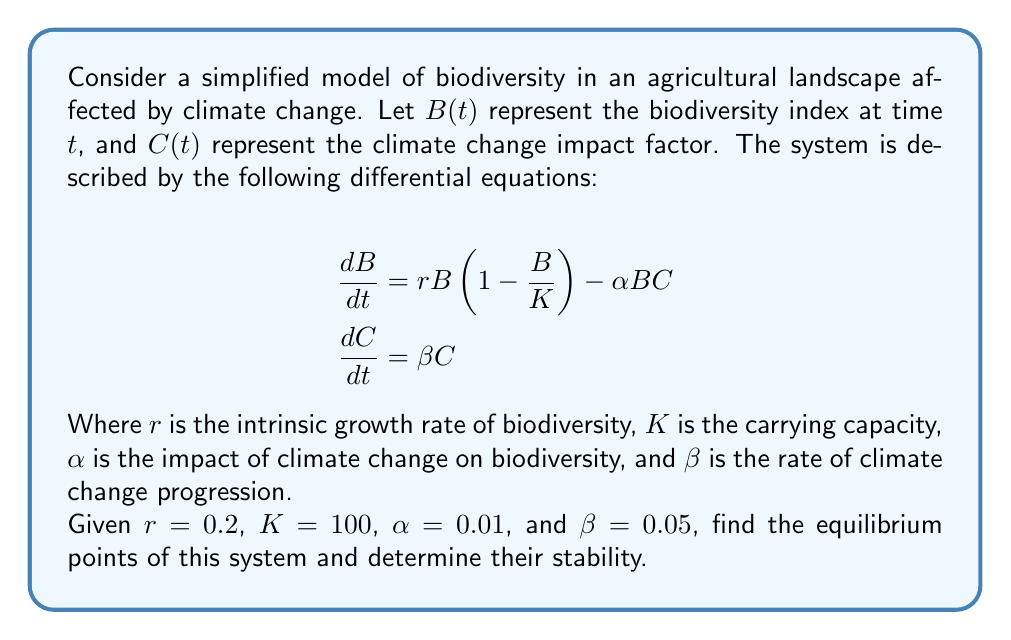Solve this math problem. To find the equilibrium points, we set both derivatives to zero:

1) $\frac{dB}{dt} = 0$ and $\frac{dC}{dt} = 0$

2) From $\frac{dC}{dt} = \beta C = 0$, we get:
   $C = 0$ (since $\beta \neq 0$)

3) Substituting this into $\frac{dB}{dt} = 0$:
   $rB(1 - \frac{B}{K}) - \alpha B(0) = 0$
   $0.2B(1 - \frac{B}{100}) = 0$

4) Solving this equation:
   $B = 0$ or $B = 100$

5) Therefore, we have two equilibrium points: $(B, C) = (0, 0)$ and $(100, 0)$

6) To determine stability, we calculate the Jacobian matrix:
   $$J = \begin{bmatrix}
   r - \frac{2rB}{K} - \alpha C & -\alpha B \\
   0 & \beta
   \end{bmatrix}$$

7) At $(0, 0)$:
   $$J_{(0,0)} = \begin{bmatrix}
   0.2 & 0 \\
   0 & 0.05
   \end{bmatrix}$$
   Eigenvalues: $\lambda_1 = 0.2$, $\lambda_2 = 0.05$
   Both positive, so $(0, 0)$ is an unstable node.

8) At $(100, 0)$:
   $$J_{(100,0)} = \begin{bmatrix}
   -0.2 & -1 \\
   0 & 0.05
   \end{bmatrix}$$
   Eigenvalues: $\lambda_1 = -0.2$, $\lambda_2 = 0.05$
   Mixed signs, so $(100, 0)$ is a saddle point.
Answer: Equilibrium points: $(0, 0)$ (unstable node) and $(100, 0)$ (saddle point). 